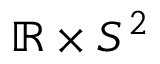<formula> <loc_0><loc_0><loc_500><loc_500>\mathbb { R } \times S ^ { 2 }</formula> 